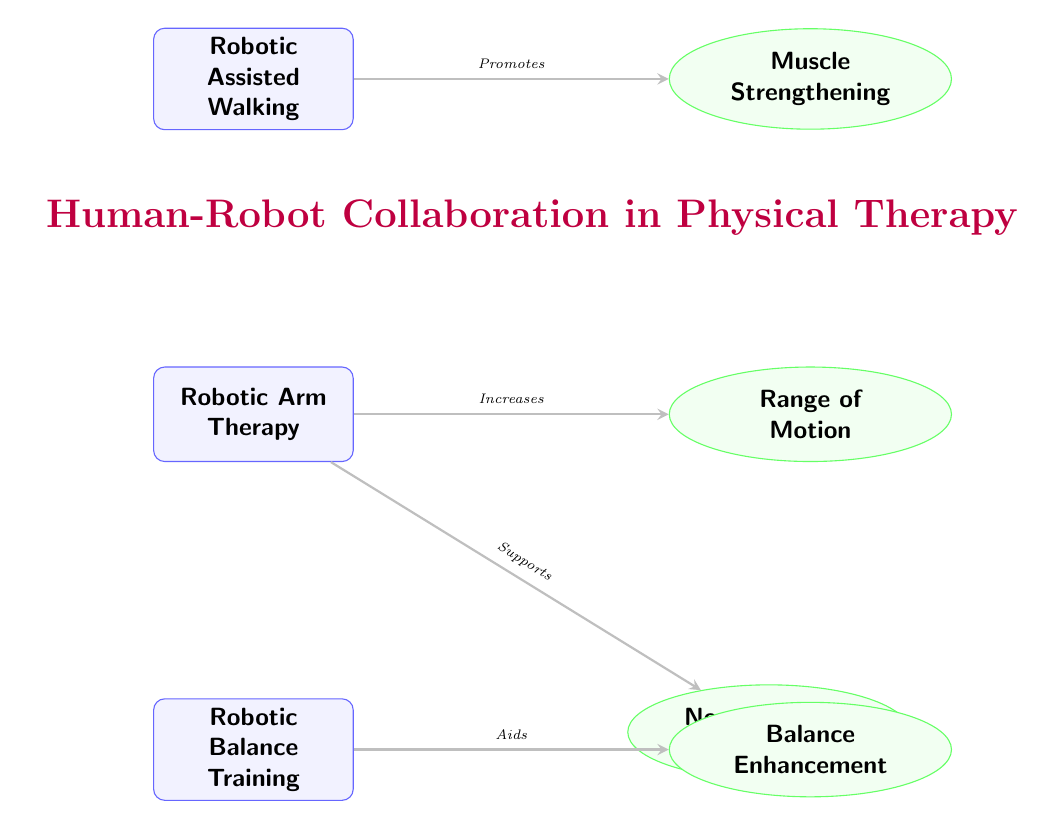What are the exercises listed in the diagram? The diagram shows three exercises: Robotic Assisted Walking, Robotic Arm Therapy, and Robotic Balance Training.
Answer: Robotic Assisted Walking, Robotic Arm Therapy, Robotic Balance Training How many benefits are associated with Robotic Arm Therapy? The diagram indicates that Robotic Arm Therapy has two associated benefits: Range of Motion and Neuromuscular Coordination.
Answer: 2 What benefit is associated with Robotic Assisted Walking? The diagram shows that Robotic Assisted Walking promotes Muscle Strengthening.
Answer: Muscle Strengthening Which exercise supports Neuromuscular Coordination? The diagram connects Robotic Arm Therapy with the benefit of Neuromuscular Coordination, indicating that it supports this benefit.
Answer: Robotic Arm Therapy What is the relationship between Robotic Balance Training and its associated benefit? The diagram shows that Robotic Balance Training aids in Balance Enhancement, indicating a supportive relationship.
Answer: Aids Which exercise promotes Muscle Strengthening? According to the diagram, Robotic Assisted Walking is the exercise that promotes Muscle Strengthening.
Answer: Robotic Assisted Walking What is the primary theme of the diagram? The highlighted title in purple indicates that the diagram's primary theme is "Human-Robot Collaboration in Physical Therapy".
Answer: Human-Robot Collaboration in Physical Therapy What color represents the benefits in the diagram? The benefits are represented using green colors for both the ellipses and the fill, as indicated in the diagram design.
Answer: Green Which exercise enhances balance? The diagram specifies that Robotic Balance Training is the exercise that enhances balance.
Answer: Robotic Balance Training What does the arrow from Robotic Arm Therapy to Range of Motion indicate? The arrow signifies an increasing relationship, meaning that Robotic Arm Therapy increases Range of Motion.
Answer: Increases 